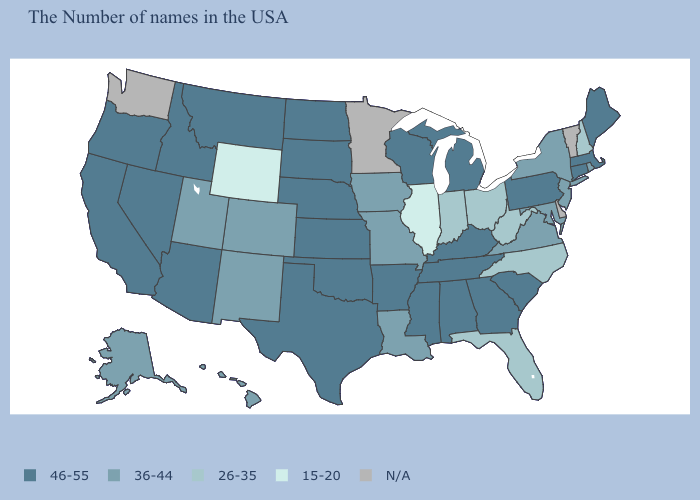Name the states that have a value in the range 46-55?
Write a very short answer. Maine, Massachusetts, Connecticut, Pennsylvania, South Carolina, Georgia, Michigan, Kentucky, Alabama, Tennessee, Wisconsin, Mississippi, Arkansas, Kansas, Nebraska, Oklahoma, Texas, South Dakota, North Dakota, Montana, Arizona, Idaho, Nevada, California, Oregon. Name the states that have a value in the range 15-20?
Be succinct. Illinois, Wyoming. What is the value of Connecticut?
Be succinct. 46-55. Among the states that border Louisiana , which have the lowest value?
Give a very brief answer. Mississippi, Arkansas, Texas. Which states have the highest value in the USA?
Short answer required. Maine, Massachusetts, Connecticut, Pennsylvania, South Carolina, Georgia, Michigan, Kentucky, Alabama, Tennessee, Wisconsin, Mississippi, Arkansas, Kansas, Nebraska, Oklahoma, Texas, South Dakota, North Dakota, Montana, Arizona, Idaho, Nevada, California, Oregon. Does Hawaii have the highest value in the West?
Quick response, please. No. What is the lowest value in the USA?
Keep it brief. 15-20. Which states have the highest value in the USA?
Be succinct. Maine, Massachusetts, Connecticut, Pennsylvania, South Carolina, Georgia, Michigan, Kentucky, Alabama, Tennessee, Wisconsin, Mississippi, Arkansas, Kansas, Nebraska, Oklahoma, Texas, South Dakota, North Dakota, Montana, Arizona, Idaho, Nevada, California, Oregon. Name the states that have a value in the range N/A?
Short answer required. Vermont, Delaware, Minnesota, Washington. What is the value of Connecticut?
Keep it brief. 46-55. What is the highest value in the MidWest ?
Answer briefly. 46-55. What is the lowest value in states that border Alabama?
Be succinct. 26-35. Which states hav the highest value in the South?
Keep it brief. South Carolina, Georgia, Kentucky, Alabama, Tennessee, Mississippi, Arkansas, Oklahoma, Texas. 